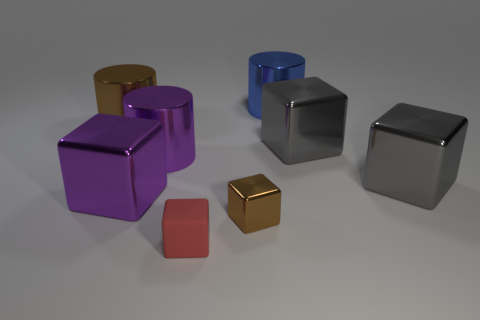Subtract all red cubes. How many cubes are left? 4 Subtract all large purple metallic blocks. How many blocks are left? 4 Subtract all blue cubes. Subtract all red cylinders. How many cubes are left? 5 Add 1 big gray metal things. How many objects exist? 9 Subtract all cubes. How many objects are left? 3 Add 8 large purple shiny cylinders. How many large purple shiny cylinders exist? 9 Subtract 0 purple spheres. How many objects are left? 8 Subtract all large gray shiny objects. Subtract all large purple things. How many objects are left? 4 Add 5 shiny cubes. How many shiny cubes are left? 9 